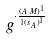<formula> <loc_0><loc_0><loc_500><loc_500>g ^ { \cdot \frac { ( A \cdot M ) ^ { 1 } } { 1 { ( s _ { A } ) } ^ { 1 } } }</formula> 